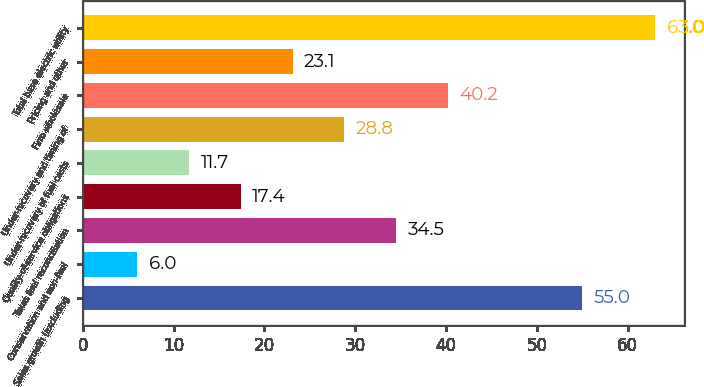Convert chart. <chart><loc_0><loc_0><loc_500><loc_500><bar_chart><fcel>Sales growth (excluding<fcel>Conservation and non-fuel<fcel>Texas fuel reconciliation<fcel>Quality-of-service obligations<fcel>Under-recovery of fuel costs<fcel>Under-recovery and timing of<fcel>Firm wholesale<fcel>Pricing and other<fcel>Total base electric utility<nl><fcel>55<fcel>6<fcel>34.5<fcel>17.4<fcel>11.7<fcel>28.8<fcel>40.2<fcel>23.1<fcel>63<nl></chart> 